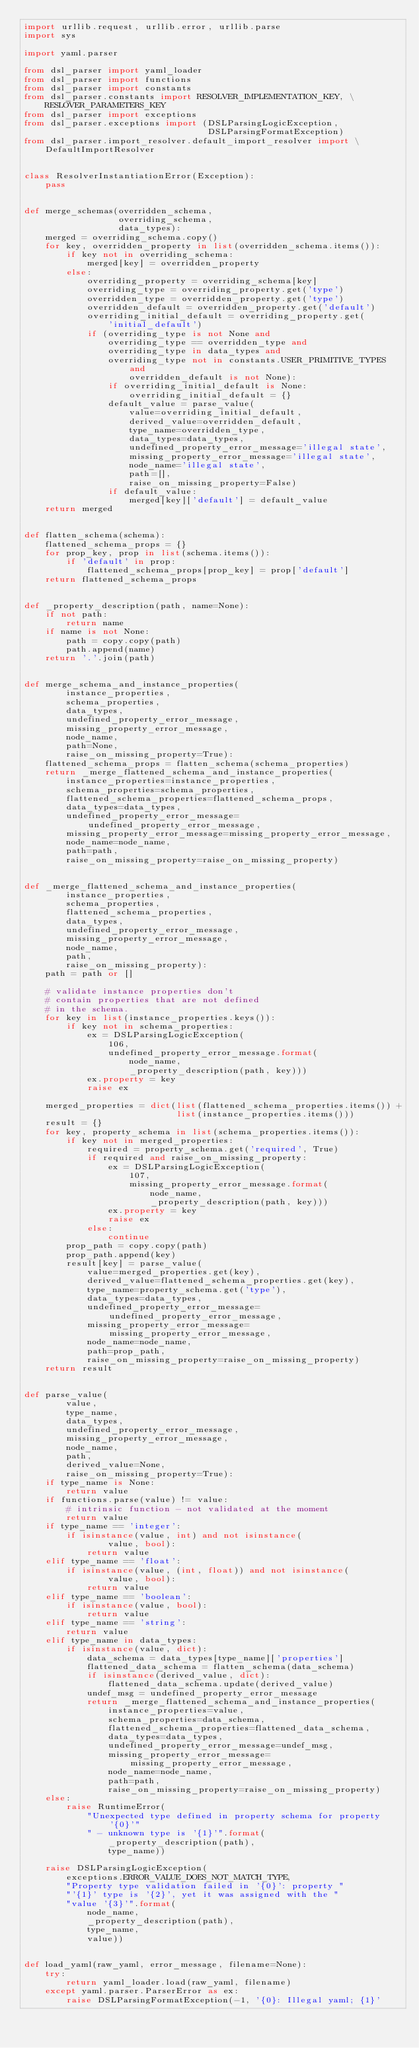<code> <loc_0><loc_0><loc_500><loc_500><_Python_>import urllib.request, urllib.error, urllib.parse
import sys

import yaml.parser

from dsl_parser import yaml_loader
from dsl_parser import functions
from dsl_parser import constants
from dsl_parser.constants import RESOLVER_IMPLEMENTATION_KEY, \
    RESLOVER_PARAMETERS_KEY
from dsl_parser import exceptions
from dsl_parser.exceptions import (DSLParsingLogicException,
                                   DSLParsingFormatException)
from dsl_parser.import_resolver.default_import_resolver import \
    DefaultImportResolver


class ResolverInstantiationError(Exception):
    pass


def merge_schemas(overridden_schema,
                  overriding_schema,
                  data_types):
    merged = overriding_schema.copy()
    for key, overridden_property in list(overridden_schema.items()):
        if key not in overriding_schema:
            merged[key] = overridden_property
        else:
            overriding_property = overriding_schema[key]
            overriding_type = overriding_property.get('type')
            overridden_type = overridden_property.get('type')
            overridden_default = overridden_property.get('default')
            overriding_initial_default = overriding_property.get(
                'initial_default')
            if (overriding_type is not None and
                overriding_type == overridden_type and
                overriding_type in data_types and
                overriding_type not in constants.USER_PRIMITIVE_TYPES and
                    overridden_default is not None):
                if overriding_initial_default is None:
                    overriding_initial_default = {}
                default_value = parse_value(
                    value=overriding_initial_default,
                    derived_value=overridden_default,
                    type_name=overridden_type,
                    data_types=data_types,
                    undefined_property_error_message='illegal state',
                    missing_property_error_message='illegal state',
                    node_name='illegal state',
                    path=[],
                    raise_on_missing_property=False)
                if default_value:
                    merged[key]['default'] = default_value
    return merged


def flatten_schema(schema):
    flattened_schema_props = {}
    for prop_key, prop in list(schema.items()):
        if 'default' in prop:
            flattened_schema_props[prop_key] = prop['default']
    return flattened_schema_props


def _property_description(path, name=None):
    if not path:
        return name
    if name is not None:
        path = copy.copy(path)
        path.append(name)
    return '.'.join(path)


def merge_schema_and_instance_properties(
        instance_properties,
        schema_properties,
        data_types,
        undefined_property_error_message,
        missing_property_error_message,
        node_name,
        path=None,
        raise_on_missing_property=True):
    flattened_schema_props = flatten_schema(schema_properties)
    return _merge_flattened_schema_and_instance_properties(
        instance_properties=instance_properties,
        schema_properties=schema_properties,
        flattened_schema_properties=flattened_schema_props,
        data_types=data_types,
        undefined_property_error_message=undefined_property_error_message,
        missing_property_error_message=missing_property_error_message,
        node_name=node_name,
        path=path,
        raise_on_missing_property=raise_on_missing_property)


def _merge_flattened_schema_and_instance_properties(
        instance_properties,
        schema_properties,
        flattened_schema_properties,
        data_types,
        undefined_property_error_message,
        missing_property_error_message,
        node_name,
        path,
        raise_on_missing_property):
    path = path or []

    # validate instance properties don't
    # contain properties that are not defined
    # in the schema.
    for key in list(instance_properties.keys()):
        if key not in schema_properties:
            ex = DSLParsingLogicException(
                106,
                undefined_property_error_message.format(
                    node_name,
                    _property_description(path, key)))
            ex.property = key
            raise ex

    merged_properties = dict(list(flattened_schema_properties.items()) +
                             list(instance_properties.items()))
    result = {}
    for key, property_schema in list(schema_properties.items()):
        if key not in merged_properties:
            required = property_schema.get('required', True)
            if required and raise_on_missing_property:
                ex = DSLParsingLogicException(
                    107,
                    missing_property_error_message.format(
                        node_name,
                        _property_description(path, key)))
                ex.property = key
                raise ex
            else:
                continue
        prop_path = copy.copy(path)
        prop_path.append(key)
        result[key] = parse_value(
            value=merged_properties.get(key),
            derived_value=flattened_schema_properties.get(key),
            type_name=property_schema.get('type'),
            data_types=data_types,
            undefined_property_error_message=undefined_property_error_message,
            missing_property_error_message=missing_property_error_message,
            node_name=node_name,
            path=prop_path,
            raise_on_missing_property=raise_on_missing_property)
    return result


def parse_value(
        value,
        type_name,
        data_types,
        undefined_property_error_message,
        missing_property_error_message,
        node_name,
        path,
        derived_value=None,
        raise_on_missing_property=True):
    if type_name is None:
        return value
    if functions.parse(value) != value:
        # intrinsic function - not validated at the moment
        return value
    if type_name == 'integer':
        if isinstance(value, int) and not isinstance(
                value, bool):
            return value
    elif type_name == 'float':
        if isinstance(value, (int, float)) and not isinstance(
                value, bool):
            return value
    elif type_name == 'boolean':
        if isinstance(value, bool):
            return value
    elif type_name == 'string':
        return value
    elif type_name in data_types:
        if isinstance(value, dict):
            data_schema = data_types[type_name]['properties']
            flattened_data_schema = flatten_schema(data_schema)
            if isinstance(derived_value, dict):
                flattened_data_schema.update(derived_value)
            undef_msg = undefined_property_error_message
            return _merge_flattened_schema_and_instance_properties(
                instance_properties=value,
                schema_properties=data_schema,
                flattened_schema_properties=flattened_data_schema,
                data_types=data_types,
                undefined_property_error_message=undef_msg,
                missing_property_error_message=missing_property_error_message,
                node_name=node_name,
                path=path,
                raise_on_missing_property=raise_on_missing_property)
    else:
        raise RuntimeError(
            "Unexpected type defined in property schema for property '{0}'"
            " - unknown type is '{1}'".format(
                _property_description(path),
                type_name))

    raise DSLParsingLogicException(
        exceptions.ERROR_VALUE_DOES_NOT_MATCH_TYPE,
        "Property type validation failed in '{0}': property "
        "'{1}' type is '{2}', yet it was assigned with the "
        "value '{3}'".format(
            node_name,
            _property_description(path),
            type_name,
            value))


def load_yaml(raw_yaml, error_message, filename=None):
    try:
        return yaml_loader.load(raw_yaml, filename)
    except yaml.parser.ParserError as ex:
        raise DSLParsingFormatException(-1, '{0}: Illegal yaml; {1}'</code> 